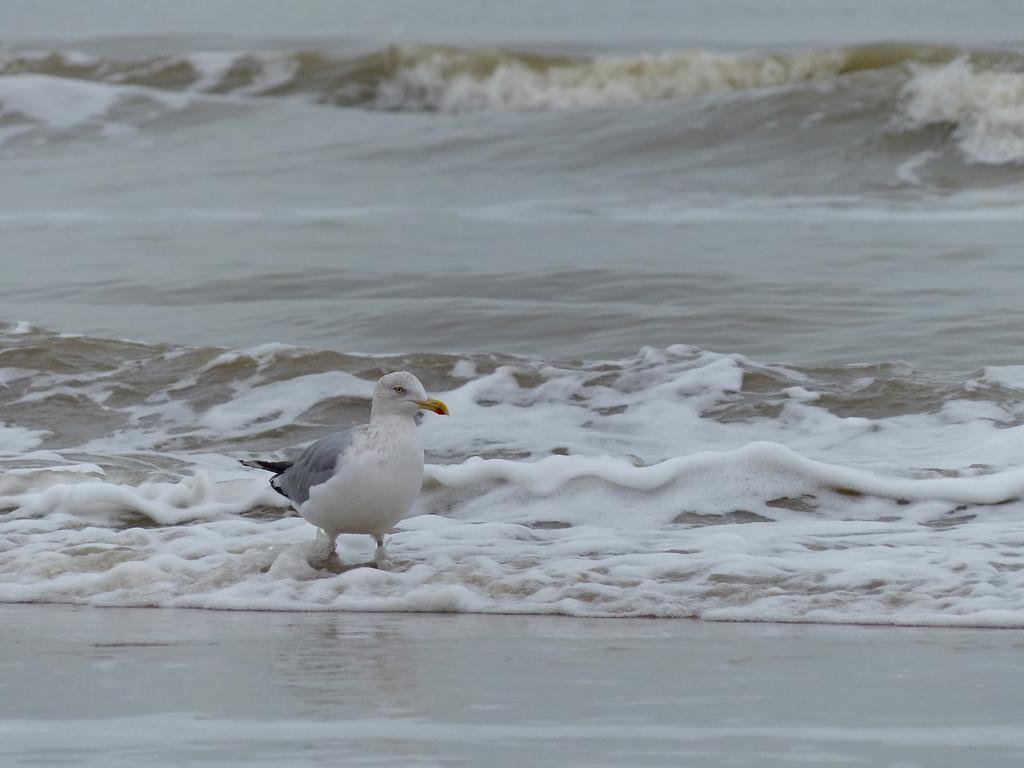What is the main subject of the image? There is a bird in the center of the image. Where is the bird located? The bird is on the water. What type of surface can be seen at the bottom of the image? There is sand at the bottom of the image. What type of branch is the bird holding in its beak in the image? There is no branch present in the image; the bird is simply on the water. 